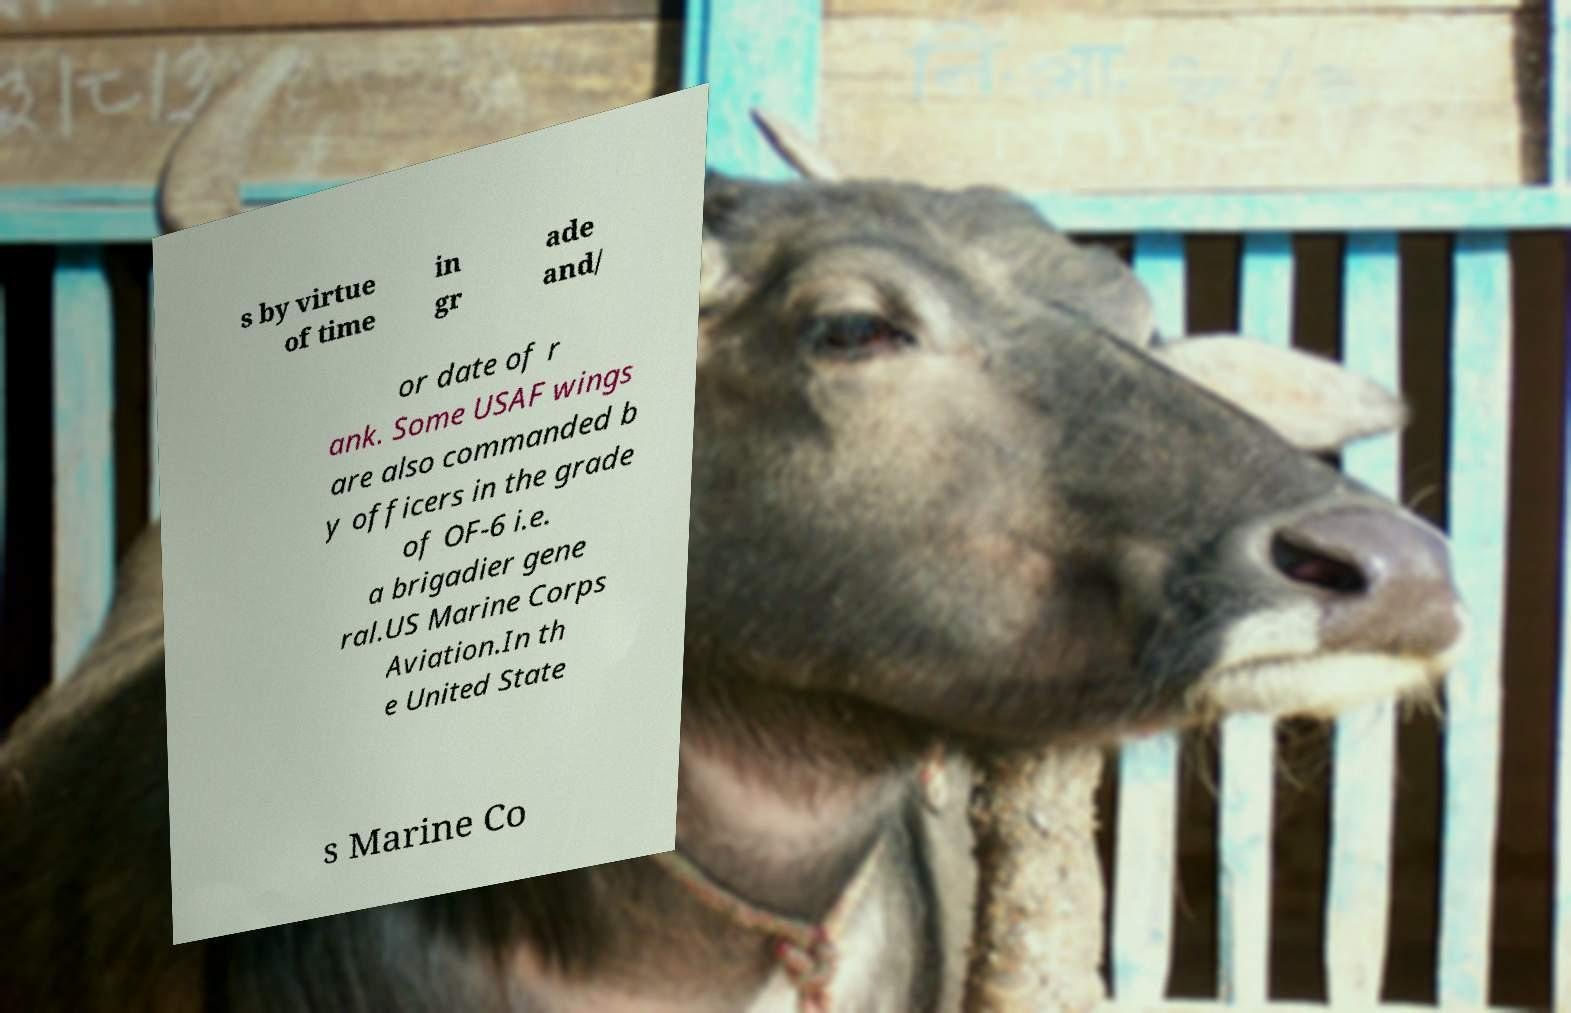What messages or text are displayed in this image? I need them in a readable, typed format. s by virtue of time in gr ade and/ or date of r ank. Some USAF wings are also commanded b y officers in the grade of OF-6 i.e. a brigadier gene ral.US Marine Corps Aviation.In th e United State s Marine Co 